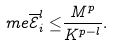Convert formula to latex. <formula><loc_0><loc_0><loc_500><loc_500>\ m e \overline { \mathcal { E } } _ { i } ^ { l } \leq & \frac { M ^ { p } } { K ^ { p - l } } .</formula> 